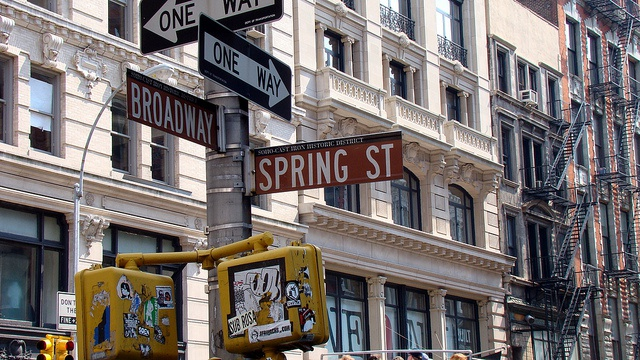Describe the objects in this image and their specific colors. I can see traffic light in lightgray, black, olive, and darkgray tones, traffic light in lightgray, olive, maroon, and black tones, traffic light in lightgray, orange, olive, black, and maroon tones, and traffic light in lightgray, black, orange, olive, and gray tones in this image. 